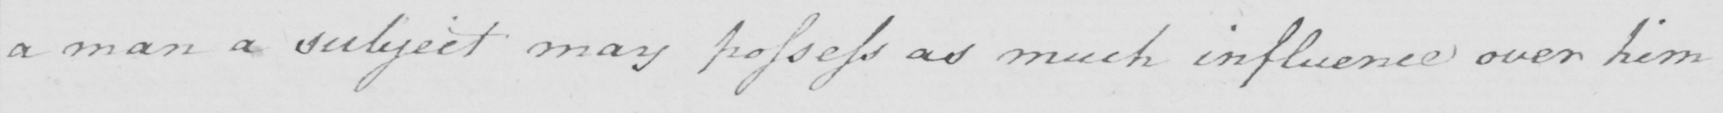Can you tell me what this handwritten text says? a man a subject may possess as much influence over him 